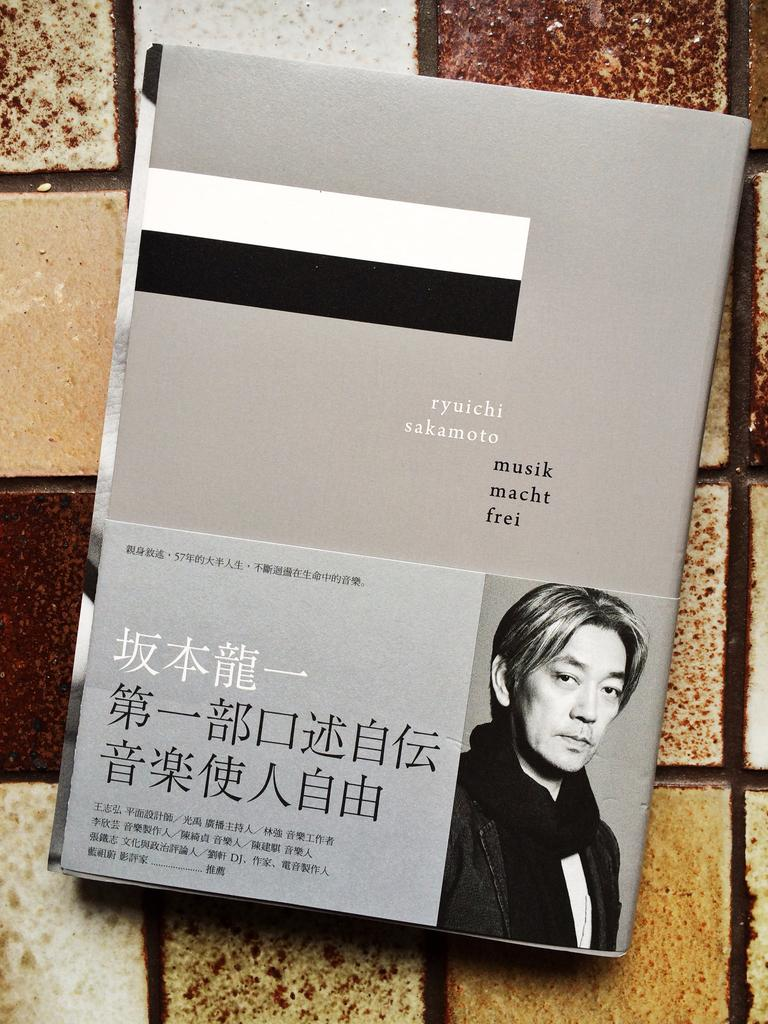What object is placed on the floor in the image? There is a book on the floor. Is the book accompanied by any other objects or figures? The image only shows a book placed on the floor. What type of tiger can be seen rubbing against the book in the image? There is no tiger present in the image, and therefore no such activity can be observed. 